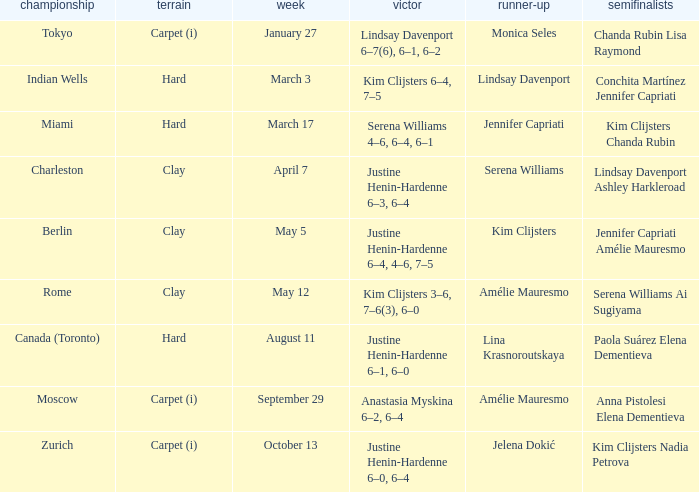Can you give me this table as a dict? {'header': ['championship', 'terrain', 'week', 'victor', 'runner-up', 'semifinalists'], 'rows': [['Tokyo', 'Carpet (i)', 'January 27', 'Lindsay Davenport 6–7(6), 6–1, 6–2', 'Monica Seles', 'Chanda Rubin Lisa Raymond'], ['Indian Wells', 'Hard', 'March 3', 'Kim Clijsters 6–4, 7–5', 'Lindsay Davenport', 'Conchita Martínez Jennifer Capriati'], ['Miami', 'Hard', 'March 17', 'Serena Williams 4–6, 6–4, 6–1', 'Jennifer Capriati', 'Kim Clijsters Chanda Rubin'], ['Charleston', 'Clay', 'April 7', 'Justine Henin-Hardenne 6–3, 6–4', 'Serena Williams', 'Lindsay Davenport Ashley Harkleroad'], ['Berlin', 'Clay', 'May 5', 'Justine Henin-Hardenne 6–4, 4–6, 7–5', 'Kim Clijsters', 'Jennifer Capriati Amélie Mauresmo'], ['Rome', 'Clay', 'May 12', 'Kim Clijsters 3–6, 7–6(3), 6–0', 'Amélie Mauresmo', 'Serena Williams Ai Sugiyama'], ['Canada (Toronto)', 'Hard', 'August 11', 'Justine Henin-Hardenne 6–1, 6–0', 'Lina Krasnoroutskaya', 'Paola Suárez Elena Dementieva'], ['Moscow', 'Carpet (i)', 'September 29', 'Anastasia Myskina 6–2, 6–4', 'Amélie Mauresmo', 'Anna Pistolesi Elena Dementieva'], ['Zurich', 'Carpet (i)', 'October 13', 'Justine Henin-Hardenne 6–0, 6–4', 'Jelena Dokić', 'Kim Clijsters Nadia Petrova']]} Who was the winner against finalist Lina Krasnoroutskaya? Justine Henin-Hardenne 6–1, 6–0. 